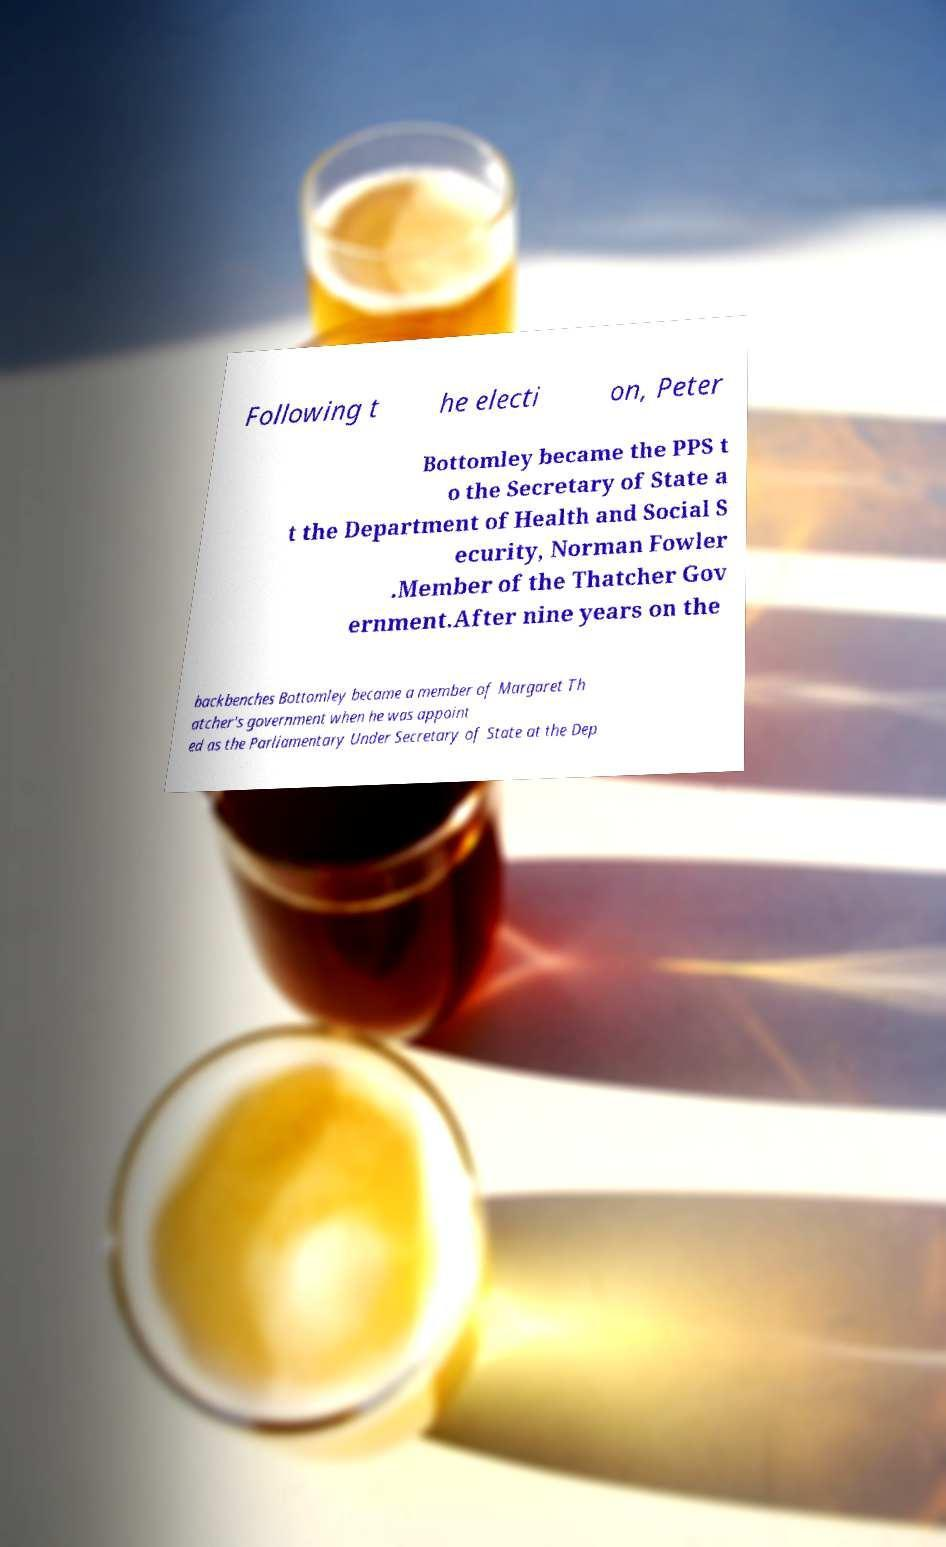Please identify and transcribe the text found in this image. Following t he electi on, Peter Bottomley became the PPS t o the Secretary of State a t the Department of Health and Social S ecurity, Norman Fowler .Member of the Thatcher Gov ernment.After nine years on the backbenches Bottomley became a member of Margaret Th atcher's government when he was appoint ed as the Parliamentary Under Secretary of State at the Dep 